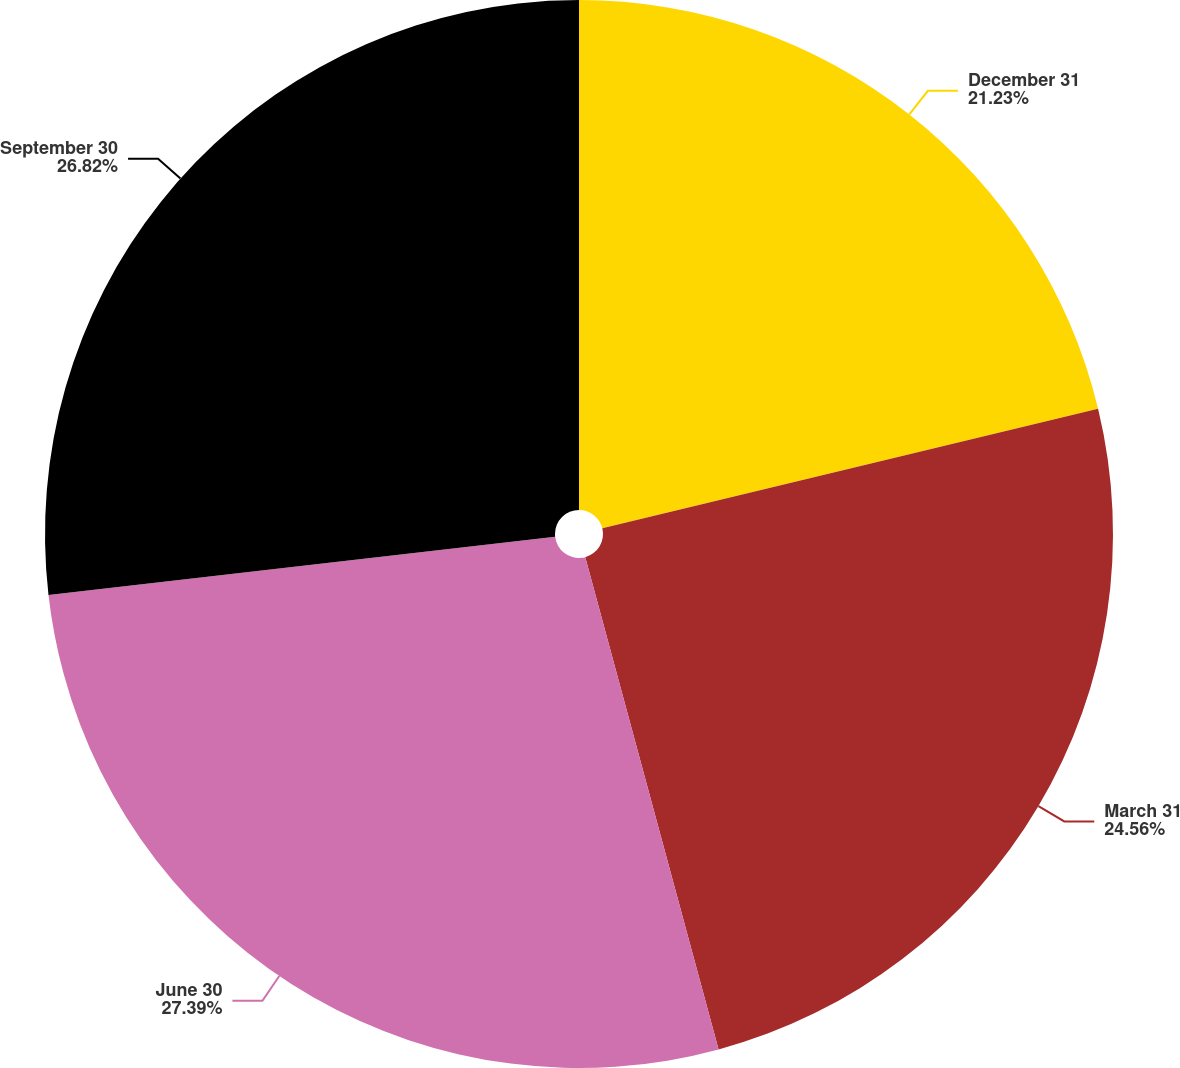<chart> <loc_0><loc_0><loc_500><loc_500><pie_chart><fcel>December 31<fcel>March 31<fcel>June 30<fcel>September 30<nl><fcel>21.23%<fcel>24.56%<fcel>27.39%<fcel>26.82%<nl></chart> 